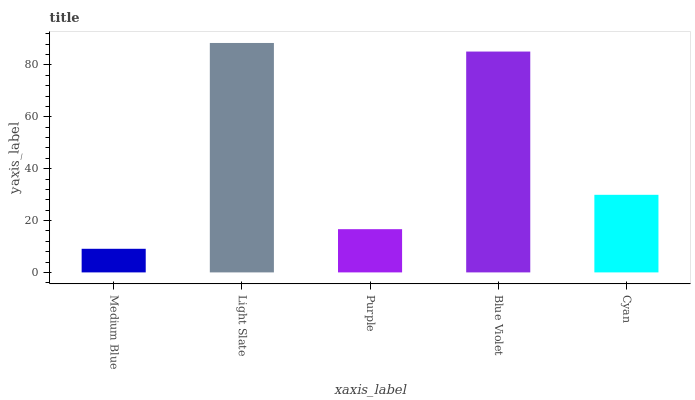Is Medium Blue the minimum?
Answer yes or no. Yes. Is Light Slate the maximum?
Answer yes or no. Yes. Is Purple the minimum?
Answer yes or no. No. Is Purple the maximum?
Answer yes or no. No. Is Light Slate greater than Purple?
Answer yes or no. Yes. Is Purple less than Light Slate?
Answer yes or no. Yes. Is Purple greater than Light Slate?
Answer yes or no. No. Is Light Slate less than Purple?
Answer yes or no. No. Is Cyan the high median?
Answer yes or no. Yes. Is Cyan the low median?
Answer yes or no. Yes. Is Blue Violet the high median?
Answer yes or no. No. Is Purple the low median?
Answer yes or no. No. 